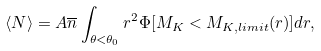<formula> <loc_0><loc_0><loc_500><loc_500>\langle N \rangle = A \overline { n } \int _ { \theta < \theta _ { 0 } } r ^ { 2 } \Phi [ M _ { K } < M _ { K , l i m i t } ( r ) ] d r ,</formula> 